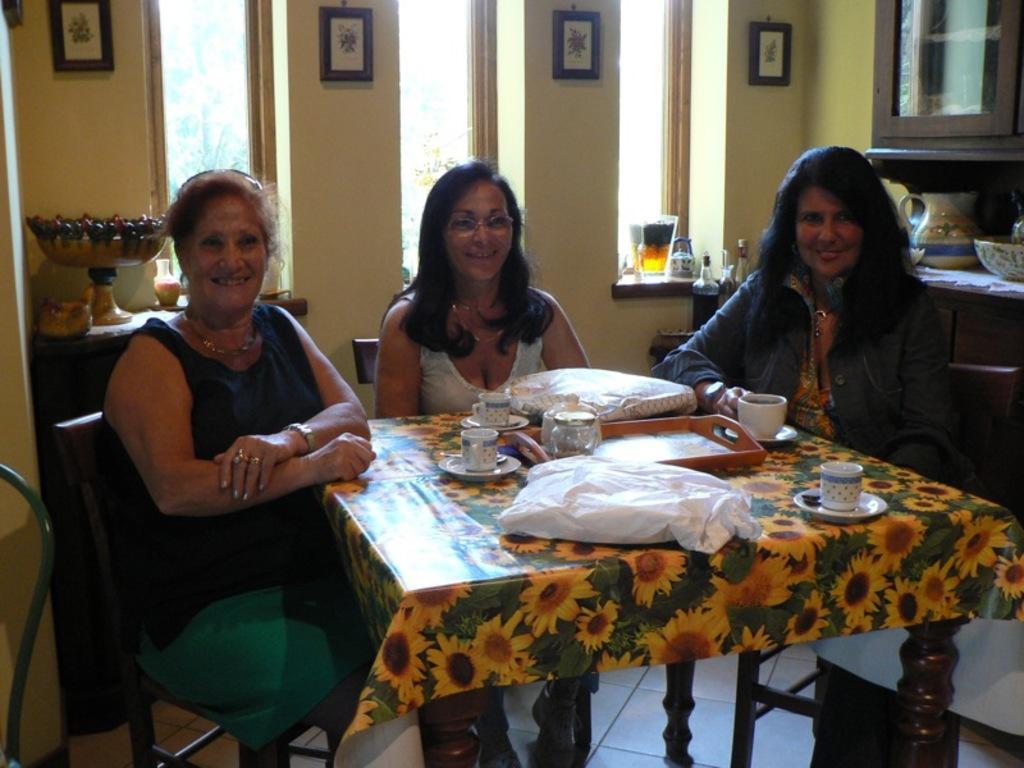In one or two sentences, can you explain what this image depicts? In this picture we can see three women are seated on the chair they are laughing, in front of them we can find couple of cups and bags on the table, in the background we can see few wall paintings on the wall, besides to them we find a jug and a bowl on the table. 